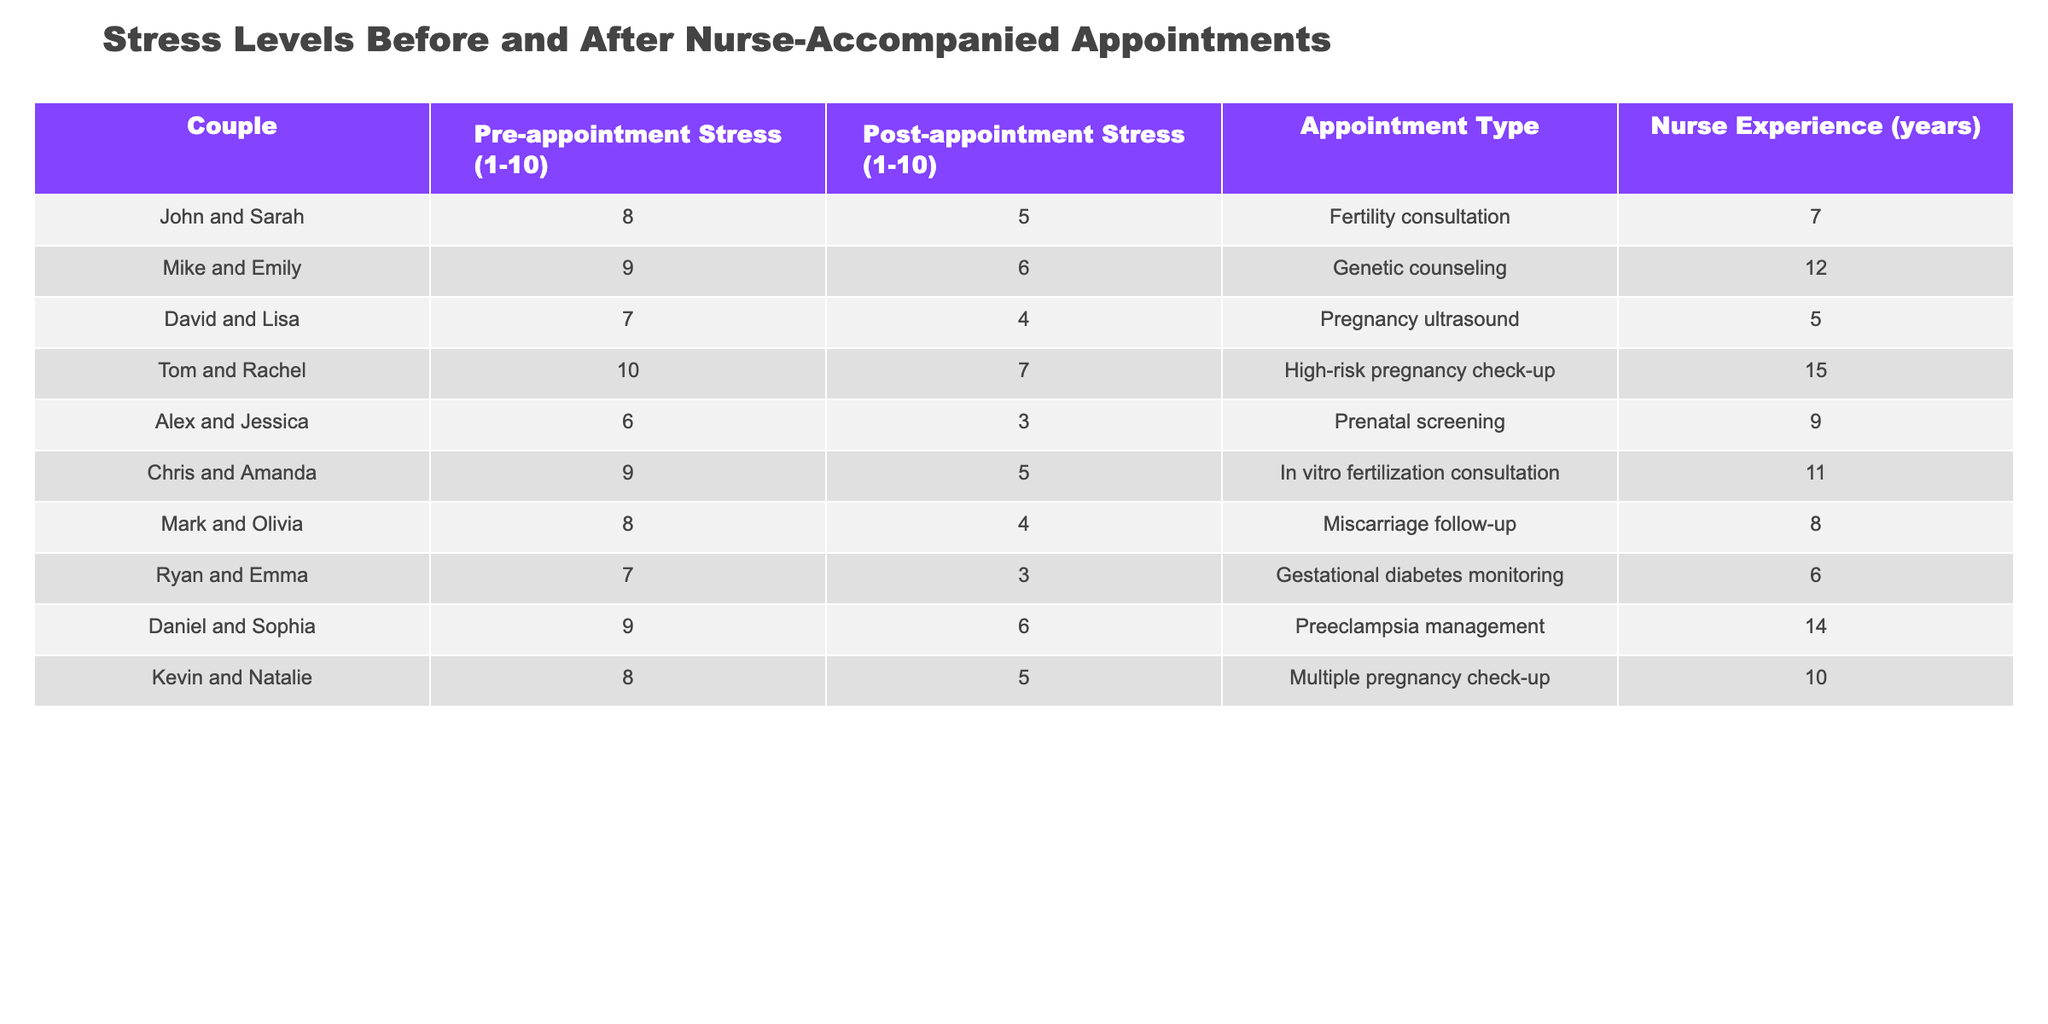What was the highest pre-appointment stress level recorded in the table? Looking at the "Pre-appointment Stress" column, the highest value is 10, which corresponds to Tom and Rachel.
Answer: 10 What is the difference in stress levels before and after appointments for Ryan and Emma? Ryan and Emma had a pre-appointment stress level of 7 and a post-appointment stress level of 3. The difference is calculated as 7 - 3 = 4.
Answer: 4 Which couple experienced the largest reduction in stress levels? By calculating the differences for each couple, David and Lisa had a reduction of 3 (7-4), Tom and Rachel had 3 (10-7), and others had equal or less reductions. David and Lisa and Tom and Rachel both had the largest reduction of 3.
Answer: David and Lisa, Tom and Rachel (3) What is the average post-appointment stress level across all couples? To find the average, sum all post-appointment stress levels (5 + 6 + 4 + 7 + 3 + 5 + 4 + 3 + 6 + 5) = 54. Then divide by the number of couples (10), which results in 54 / 10 = 5.4.
Answer: 5.4 Did any couple have a post-appointment stress level that was still more than 5? Checking the post-appointment stress levels, both Tom and Rachel (7) and Chris and Amanda (5) still have levels equal or above 5. Hence, yes, there were couples with those stress levels.
Answer: Yes What is the median pre-appointment stress level for the couples in this table? To find the median, we first sort the pre-appointment stress levels: [6, 7, 7, 8, 8, 8, 9, 9, 9, 10]. The median of an even number of values is the average of the two middle numbers (8 and 8), resulting in a median of 8.
Answer: 8 Which appointment type had the lowest post-appointment stress level? Looking at the "Post-appointment Stress" column, the lowest value recorded is 3, which corresponds to Ryan and Emma for the "Gestational diabetes monitoring."
Answer: Gestational diabetes monitoring How many years of nurse experience did the couple with the highest pre-appointment stress level have? The couple with the highest pre-appointment stress level is Tom and Rachel with a level of 10 and they had 15 years of nurse experience.
Answer: 15 